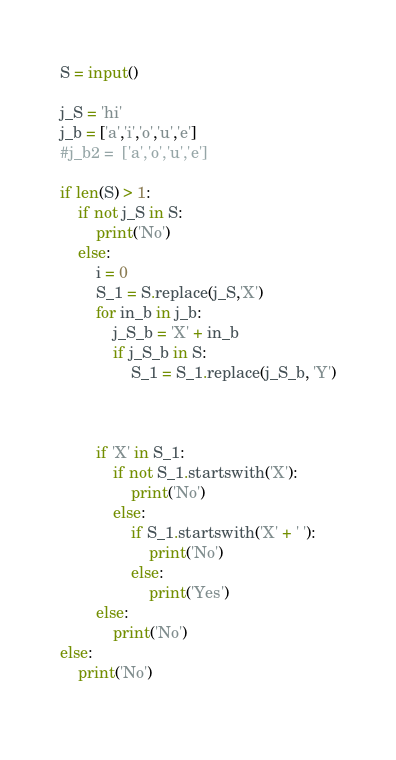<code> <loc_0><loc_0><loc_500><loc_500><_Python_>S = input()
 
j_S = 'hi'
j_b = ['a','i','o','u','e']
#j_b2 =  ['a','o','u','e']

if len(S) > 1:
    if not j_S in S:
        print('No')    
    else:
        i = 0
        S_1 = S.replace(j_S,'X')
        for in_b in j_b:
            j_S_b = 'X' + in_b
            if j_S_b in S:
                S_1 = S_1.replace(j_S_b, 'Y')
        
        
        
        if 'X' in S_1:
            if not S_1.startswith('X'):
                print('No')
            else:
                if S_1.startswith('X' + ' '):
                    print('No')
                else:
                    print('Yes')
        else:
            print('No')
else:
    print('No')
 </code> 